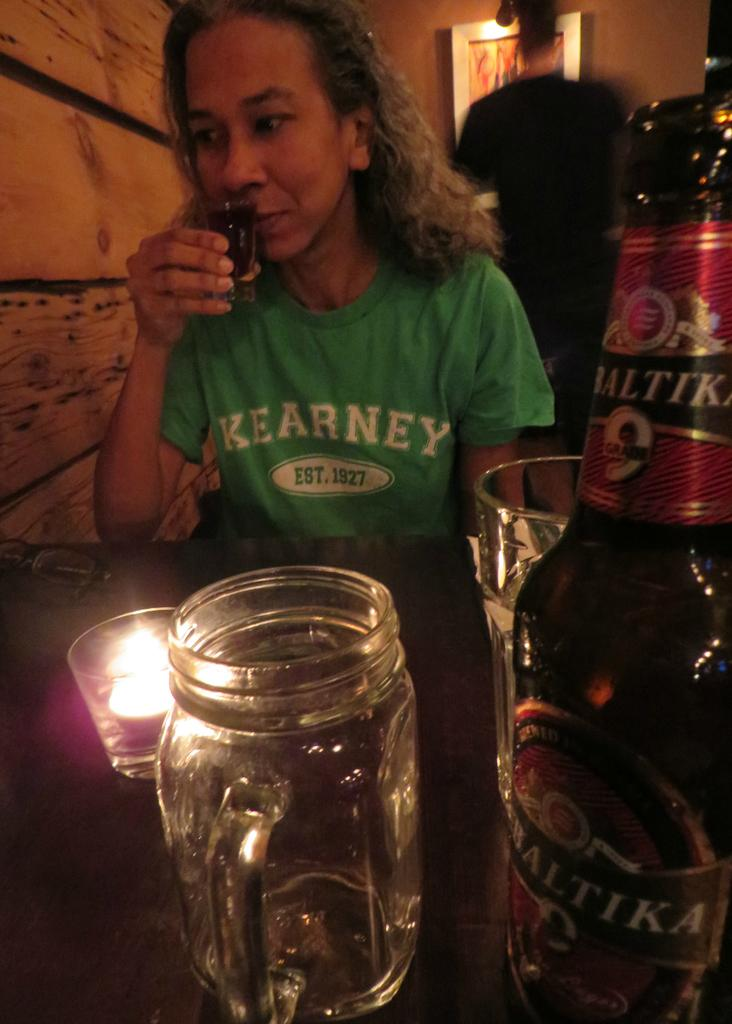<image>
Create a compact narrative representing the image presented. a woman wearing a green shirt that says 'kearney est. 1927' on it 